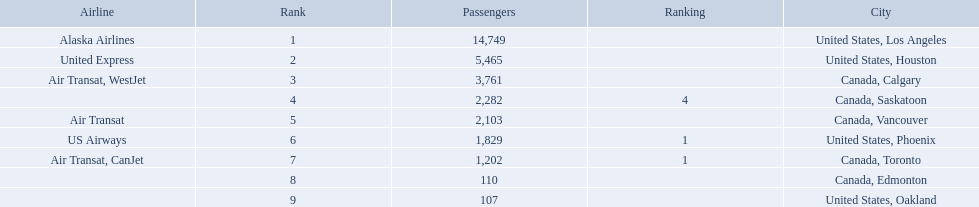What are the cities flown to? United States, Los Angeles, United States, Houston, Canada, Calgary, Canada, Saskatoon, Canada, Vancouver, United States, Phoenix, Canada, Toronto, Canada, Edmonton, United States, Oakland. What number of passengers did pheonix have? 1,829. 